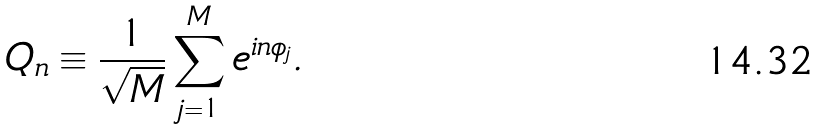<formula> <loc_0><loc_0><loc_500><loc_500>Q _ { n } \equiv \frac { 1 } { \sqrt { M } } \sum _ { j = 1 } ^ { M } e ^ { i n \phi _ { j } } .</formula> 